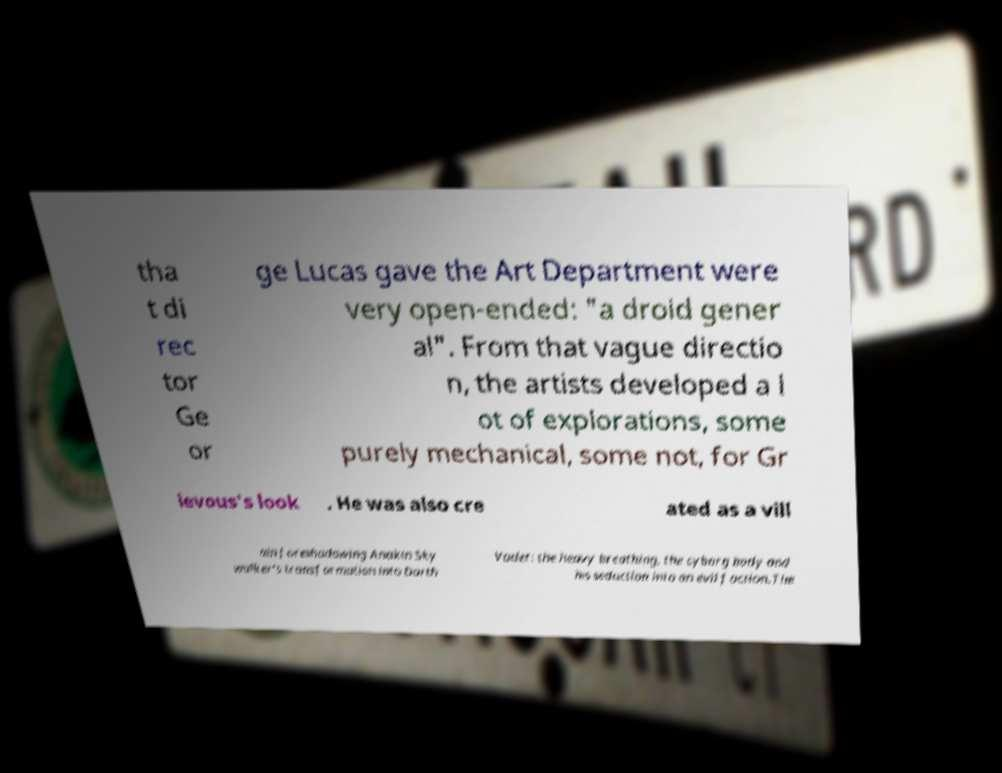Can you read and provide the text displayed in the image?This photo seems to have some interesting text. Can you extract and type it out for me? tha t di rec tor Ge or ge Lucas gave the Art Department were very open-ended: "a droid gener al". From that vague directio n, the artists developed a l ot of explorations, some purely mechanical, some not, for Gr ievous's look . He was also cre ated as a vill ain foreshadowing Anakin Sky walker's transformation into Darth Vader: the heavy breathing, the cyborg body and his seduction into an evil faction.The 